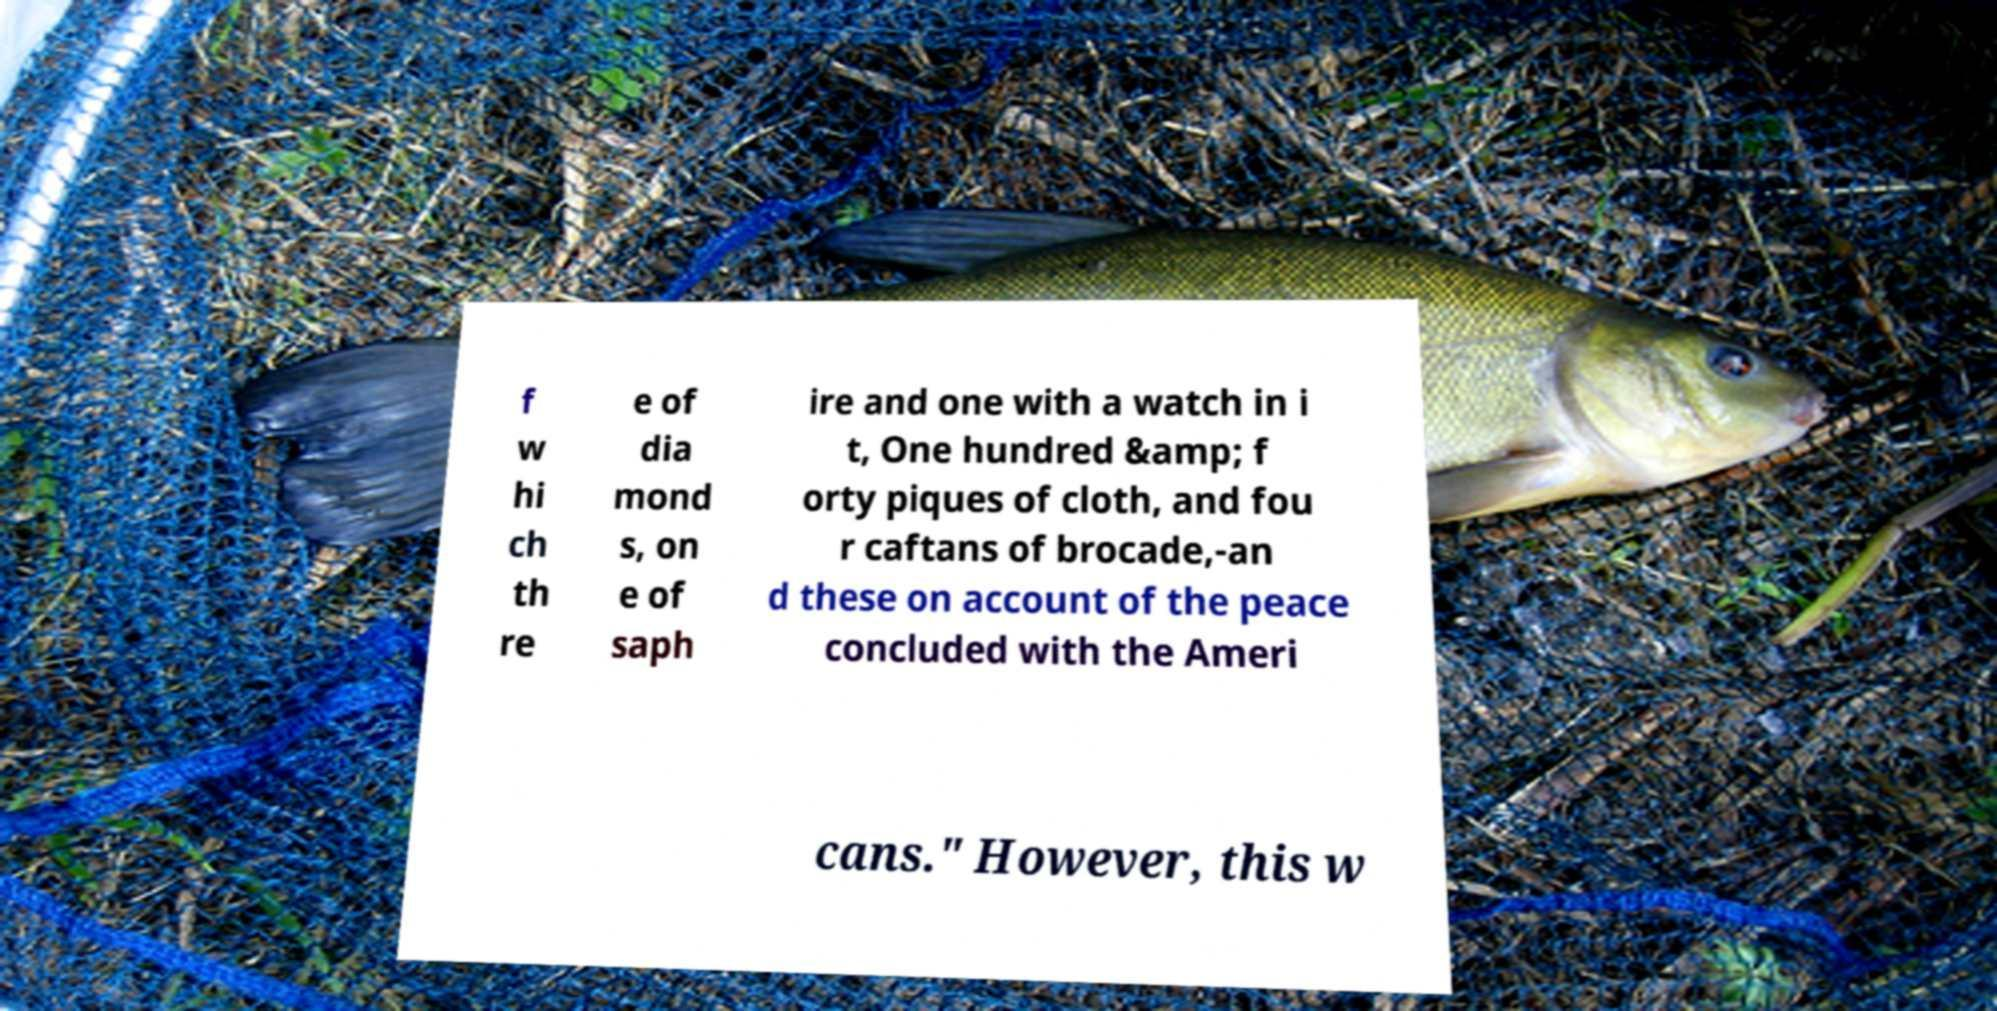Please read and relay the text visible in this image. What does it say? f w hi ch th re e of dia mond s, on e of saph ire and one with a watch in i t, One hundred &amp; f orty piques of cloth, and fou r caftans of brocade,-an d these on account of the peace concluded with the Ameri cans." However, this w 